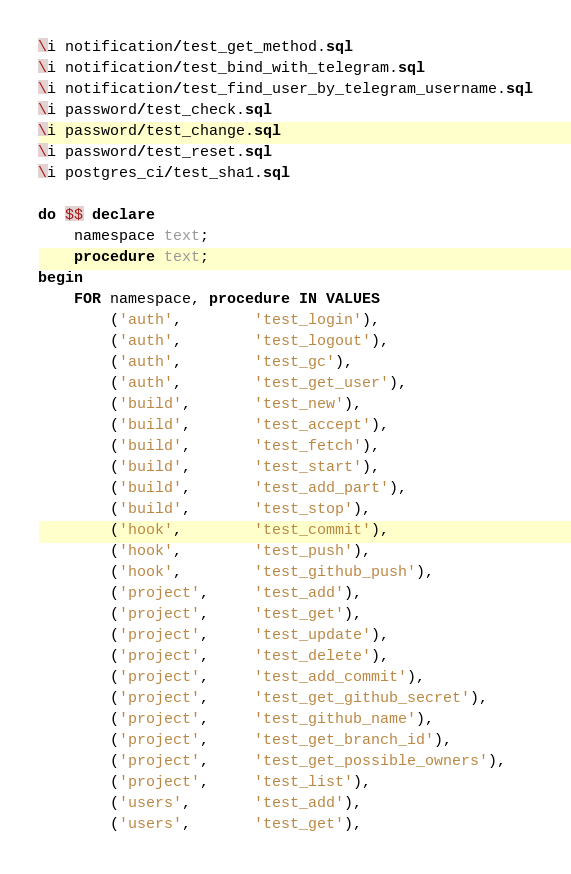<code> <loc_0><loc_0><loc_500><loc_500><_SQL_>\i notification/test_get_method.sql
\i notification/test_bind_with_telegram.sql
\i notification/test_find_user_by_telegram_username.sql
\i password/test_check.sql
\i password/test_change.sql
\i password/test_reset.sql
\i postgres_ci/test_sha1.sql

do $$ declare
    namespace text;
    procedure text;
begin
    FOR namespace, procedure IN VALUES 
        ('auth',        'test_login'),
        ('auth',        'test_logout'),
        ('auth',        'test_gc'),
        ('auth',        'test_get_user'),
        ('build',       'test_new'),
        ('build',       'test_accept'),
        ('build',       'test_fetch'),
        ('build',       'test_start'),
        ('build',       'test_add_part'),
        ('build',       'test_stop'),
        ('hook',        'test_commit'),
        ('hook',        'test_push'),
        ('hook',        'test_github_push'),
        ('project',     'test_add'),
        ('project',     'test_get'),
        ('project',     'test_update'),
        ('project',     'test_delete'),
        ('project',     'test_add_commit'),
        ('project',     'test_get_github_secret'),
        ('project',     'test_github_name'),
        ('project',     'test_get_branch_id'),
        ('project',     'test_get_possible_owners'),
        ('project',     'test_list'),
        ('users',       'test_add'),
        ('users',       'test_get'),</code> 